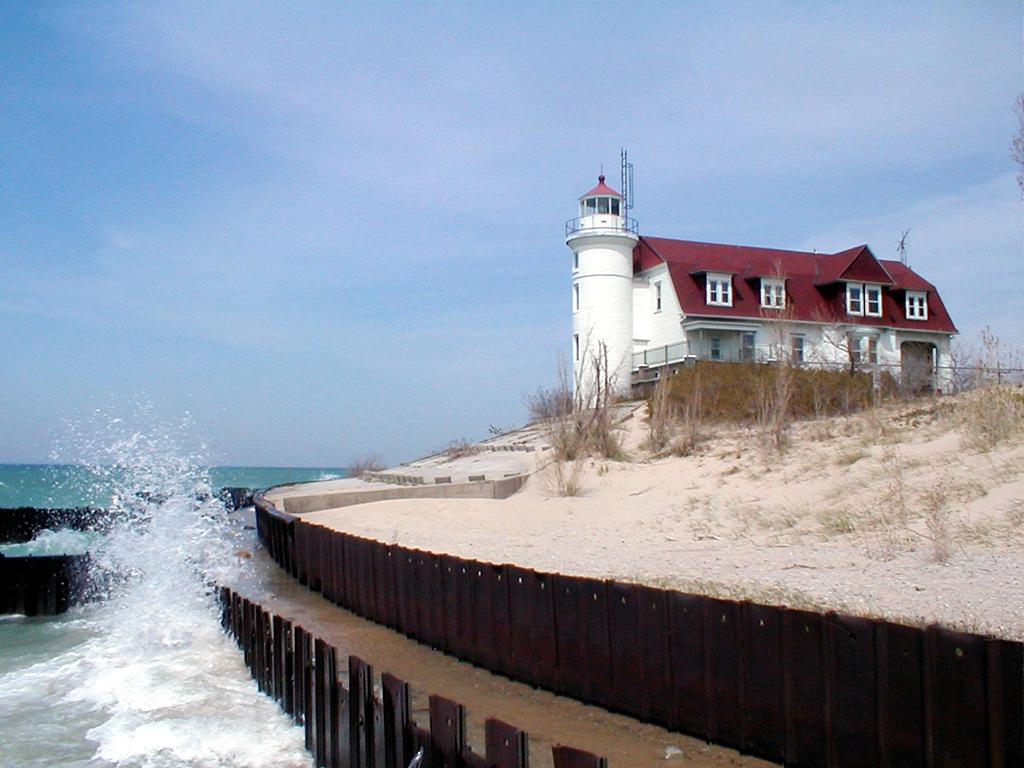What type of structure is present in the image? There is a lighthouse in the image. What other type of structure can be seen in the image? There is a building in the image. What is the purpose of the fence in the image? The fence is likely used to enclose or separate areas in the image. What natural element is visible in the image? There is water visible in the image. What type of vegetation is present in the image? There are plants in the image. What is visible in the background of the image? The sky is visible in the background of the image. What type of ring can be seen on the lighthouse in the image? There is no ring present on the lighthouse in the image. How many books are visible in the image? There are no books present in the image. 